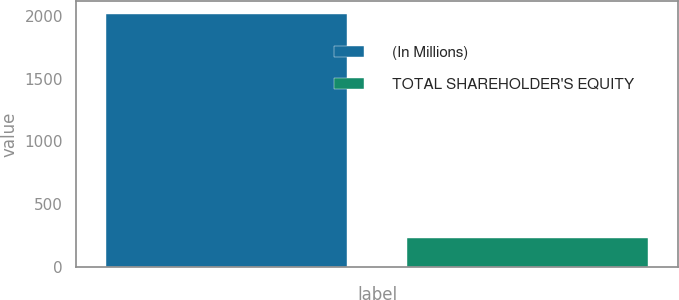Convert chart to OTSL. <chart><loc_0><loc_0><loc_500><loc_500><bar_chart><fcel>(In Millions)<fcel>TOTAL SHAREHOLDER'S EQUITY<nl><fcel>2014<fcel>235<nl></chart> 